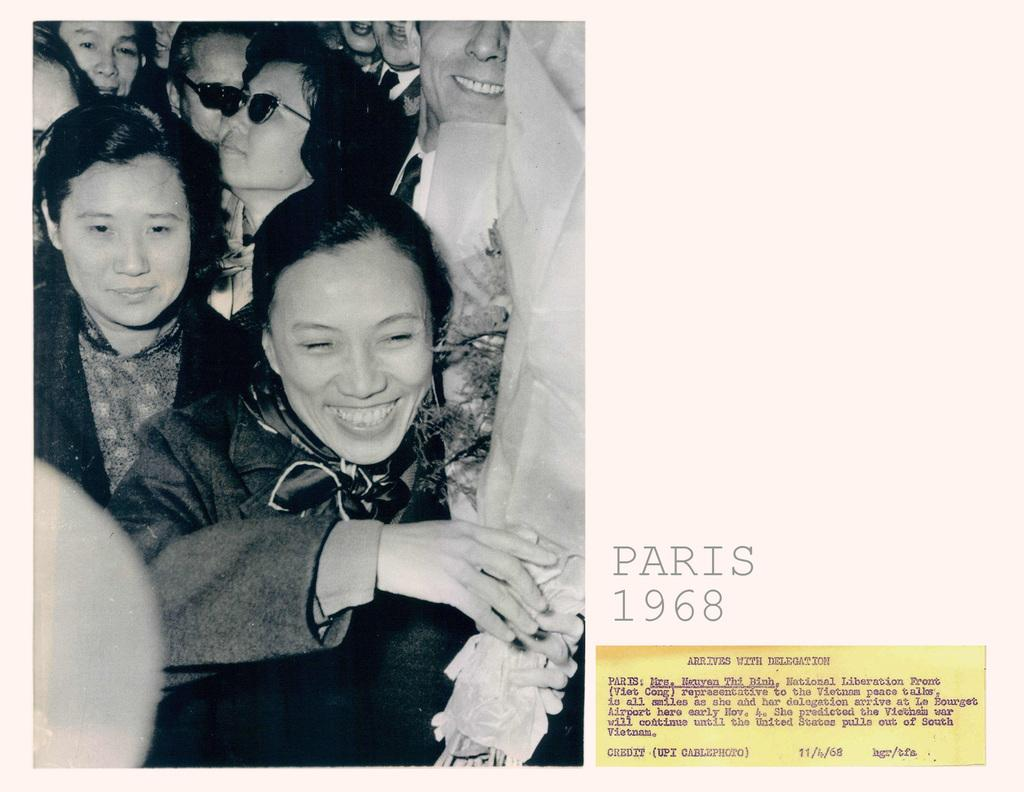Who or what is located on the left side of the image? There are people on the left side of the image. What are the people doing in the image? Some of the people are standing, and some of them are smiling. What can be seen on the right side of the image? There is text on the right side of the image. What type of marble is visible in the image? There is no marble present in the image. How many people are there in the image, and what is the number of people standing? The number of people and the number of people standing cannot be determined from the provided facts. 